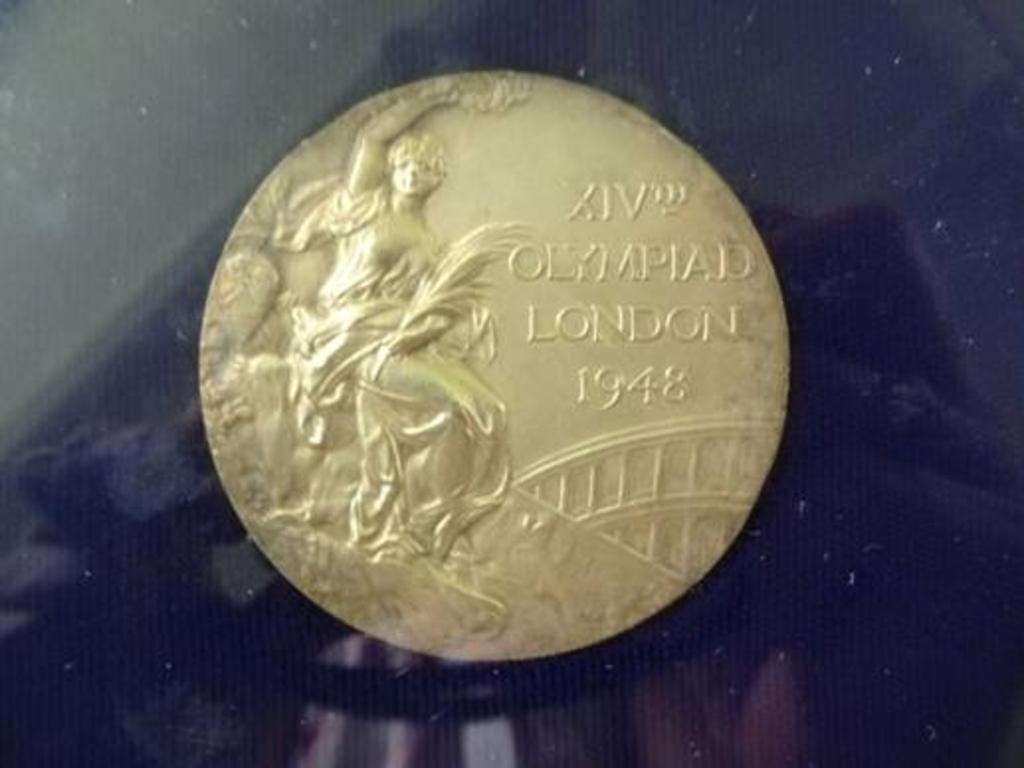<image>
Give a short and clear explanation of the subsequent image. A gold coin that says XIV Olympaid London from 1948. 